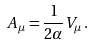<formula> <loc_0><loc_0><loc_500><loc_500>A _ { \mu } = \frac { 1 } { 2 \alpha } V _ { \mu } \, .</formula> 